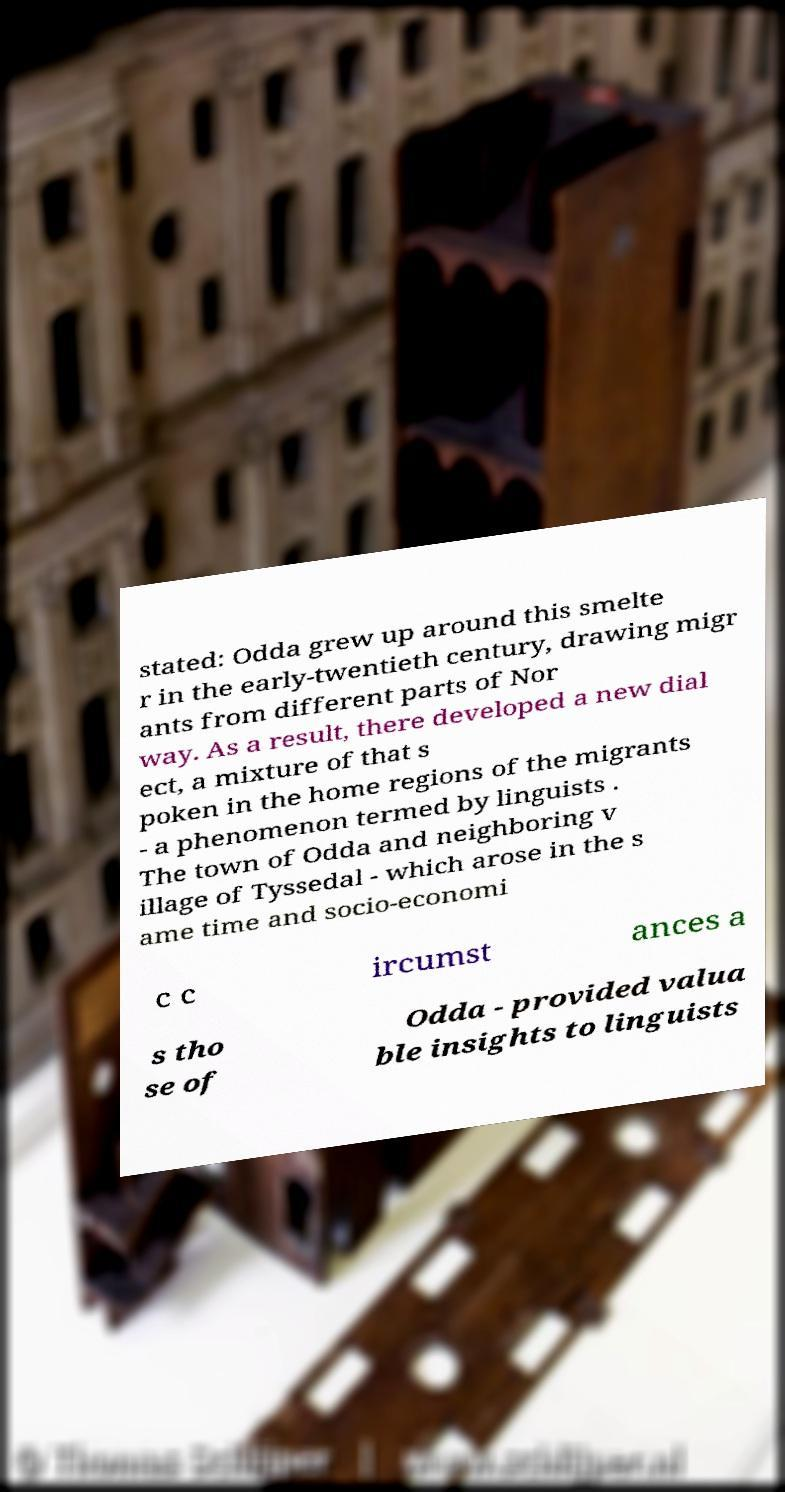Can you accurately transcribe the text from the provided image for me? stated: Odda grew up around this smelte r in the early-twentieth century, drawing migr ants from different parts of Nor way. As a result, there developed a new dial ect, a mixture of that s poken in the home regions of the migrants - a phenomenon termed by linguists . The town of Odda and neighboring v illage of Tyssedal - which arose in the s ame time and socio-economi c c ircumst ances a s tho se of Odda - provided valua ble insights to linguists 